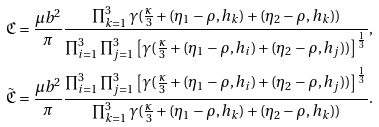Convert formula to latex. <formula><loc_0><loc_0><loc_500><loc_500>& \mathfrak { C } = \frac { \mu b ^ { 2 } } { \pi } \frac { \prod _ { k = 1 } ^ { 3 } \gamma ( \frac { \kappa } { 3 } + ( \eta _ { 1 } - \rho , h _ { k } ) + ( \eta _ { 2 } - \rho , h _ { k } ) ) } { \prod _ { i = 1 } ^ { 3 } \prod _ { j = 1 } ^ { 3 } \left [ \gamma ( \frac { \kappa } { 3 } + ( \eta _ { 1 } - \rho , h _ { i } ) + ( \eta _ { 2 } - \rho , h _ { j } ) ) \right ] ^ { \frac { 1 } { 3 } } } , \\ & \tilde { \mathfrak { C } } = \frac { \mu b ^ { 2 } } { \pi } \frac { \prod _ { i = 1 } ^ { 3 } \prod _ { j = 1 } ^ { 3 } \left [ \gamma ( \frac { \kappa } { 3 } + ( \eta _ { 1 } - \rho , h _ { i } ) + ( \eta _ { 2 } - \rho , h _ { j } ) ) \right ] ^ { \frac { 1 } { 3 } } } { \prod _ { k = 1 } ^ { 3 } \gamma ( \frac { \kappa } { 3 } + ( \eta _ { 1 } - \rho , h _ { k } ) + ( \eta _ { 2 } - \rho , h _ { k } ) ) } .</formula> 